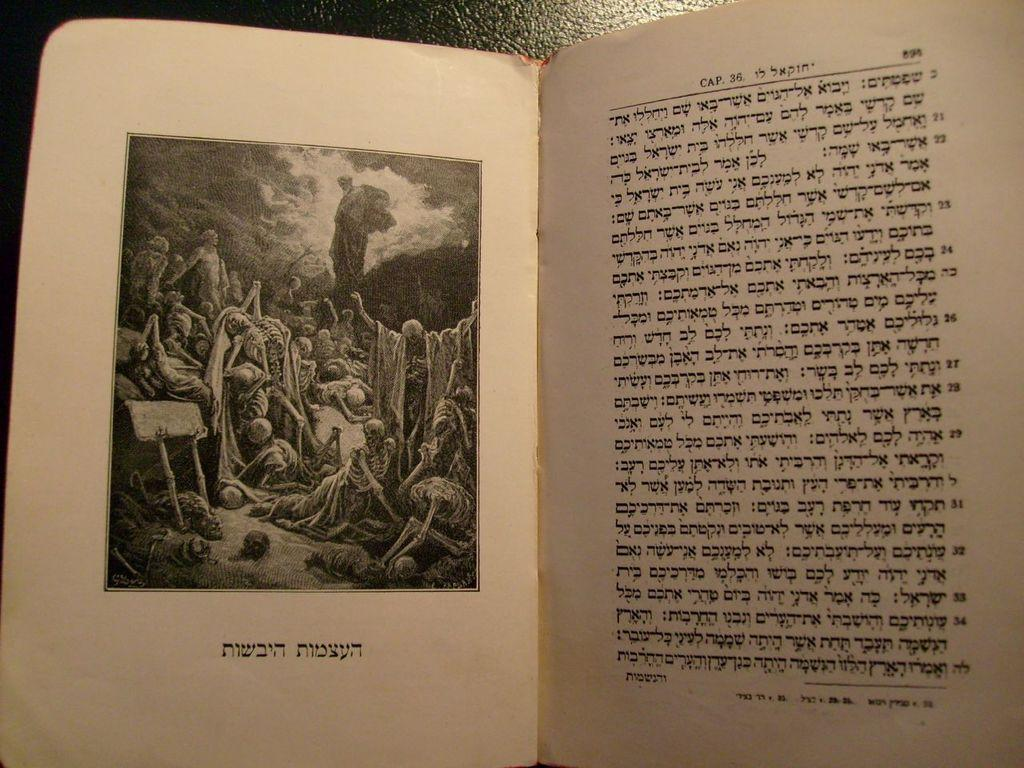<image>
Summarize the visual content of the image. some foreign language that is in a book 